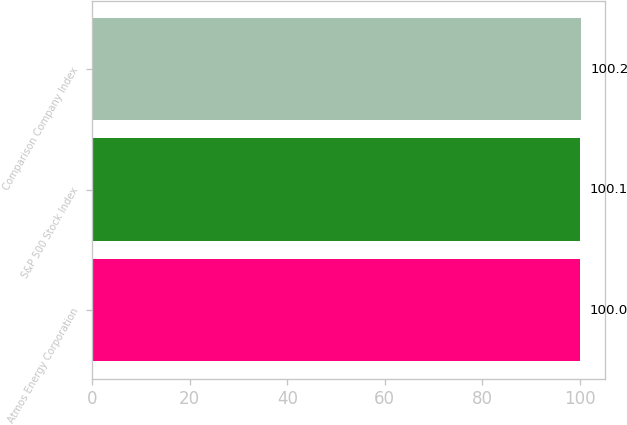<chart> <loc_0><loc_0><loc_500><loc_500><bar_chart><fcel>Atmos Energy Corporation<fcel>S&P 500 Stock Index<fcel>Comparison Company Index<nl><fcel>100<fcel>100.1<fcel>100.2<nl></chart> 